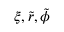<formula> <loc_0><loc_0><loc_500><loc_500>\xi , \tilde { r } , \tilde { \phi }</formula> 